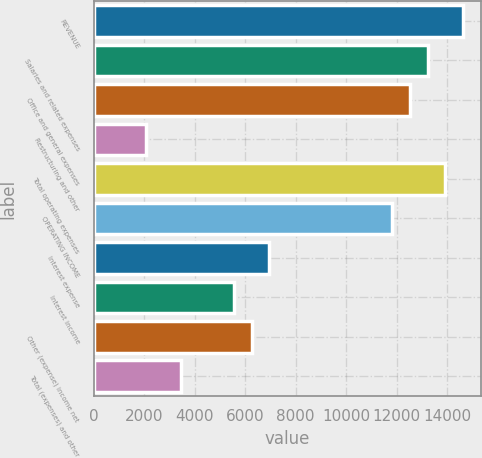<chart> <loc_0><loc_0><loc_500><loc_500><bar_chart><fcel>REVENUE<fcel>Salaries and related expenses<fcel>Office and general expenses<fcel>Restructuring and other<fcel>Total operating expenses<fcel>OPERATING INCOME<fcel>Interest expense<fcel>Interest income<fcel>Other (expense) income net<fcel>Total (expenses) and other<nl><fcel>14607.8<fcel>13216.6<fcel>12521<fcel>2087.04<fcel>13912.2<fcel>11825.4<fcel>6956.24<fcel>5565.04<fcel>6260.64<fcel>3478.24<nl></chart> 